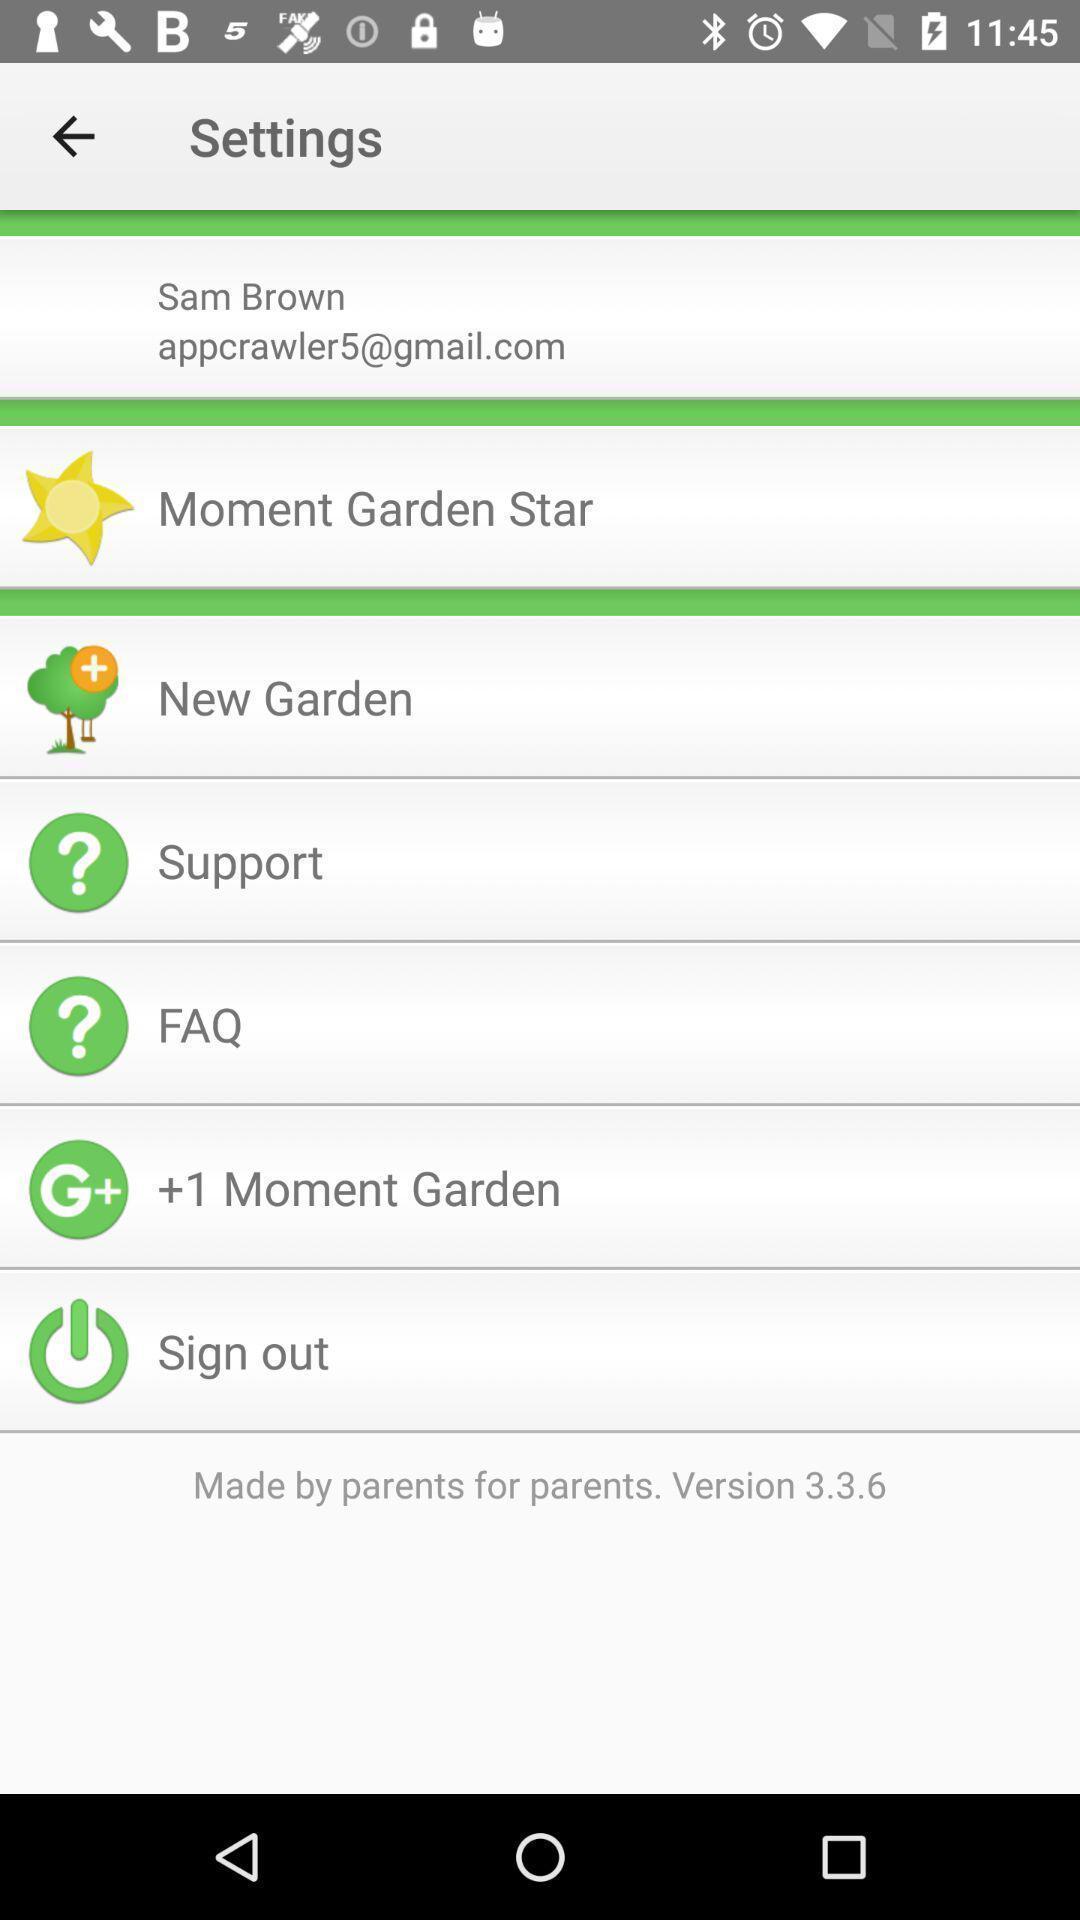Give me a summary of this screen capture. Settings page is displaying. 